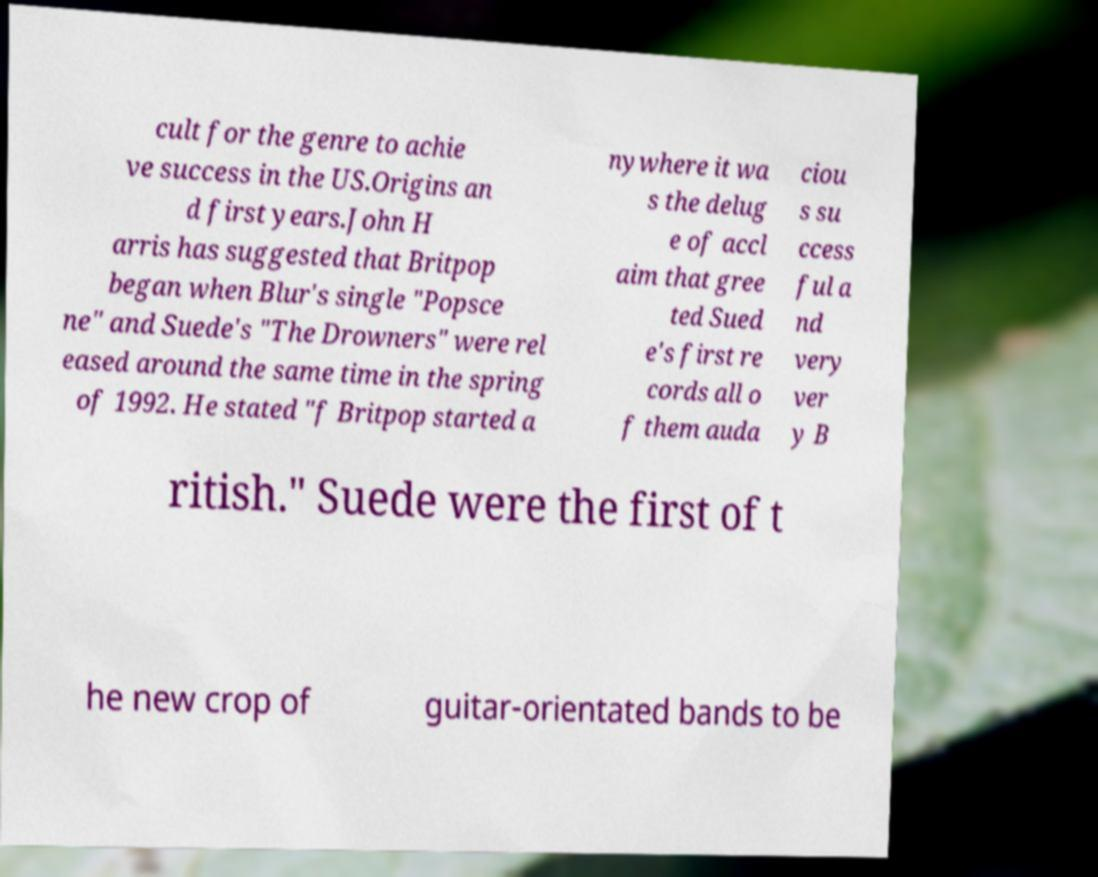What messages or text are displayed in this image? I need them in a readable, typed format. cult for the genre to achie ve success in the US.Origins an d first years.John H arris has suggested that Britpop began when Blur's single "Popsce ne" and Suede's "The Drowners" were rel eased around the same time in the spring of 1992. He stated "f Britpop started a nywhere it wa s the delug e of accl aim that gree ted Sued e's first re cords all o f them auda ciou s su ccess ful a nd very ver y B ritish." Suede were the first of t he new crop of guitar-orientated bands to be 